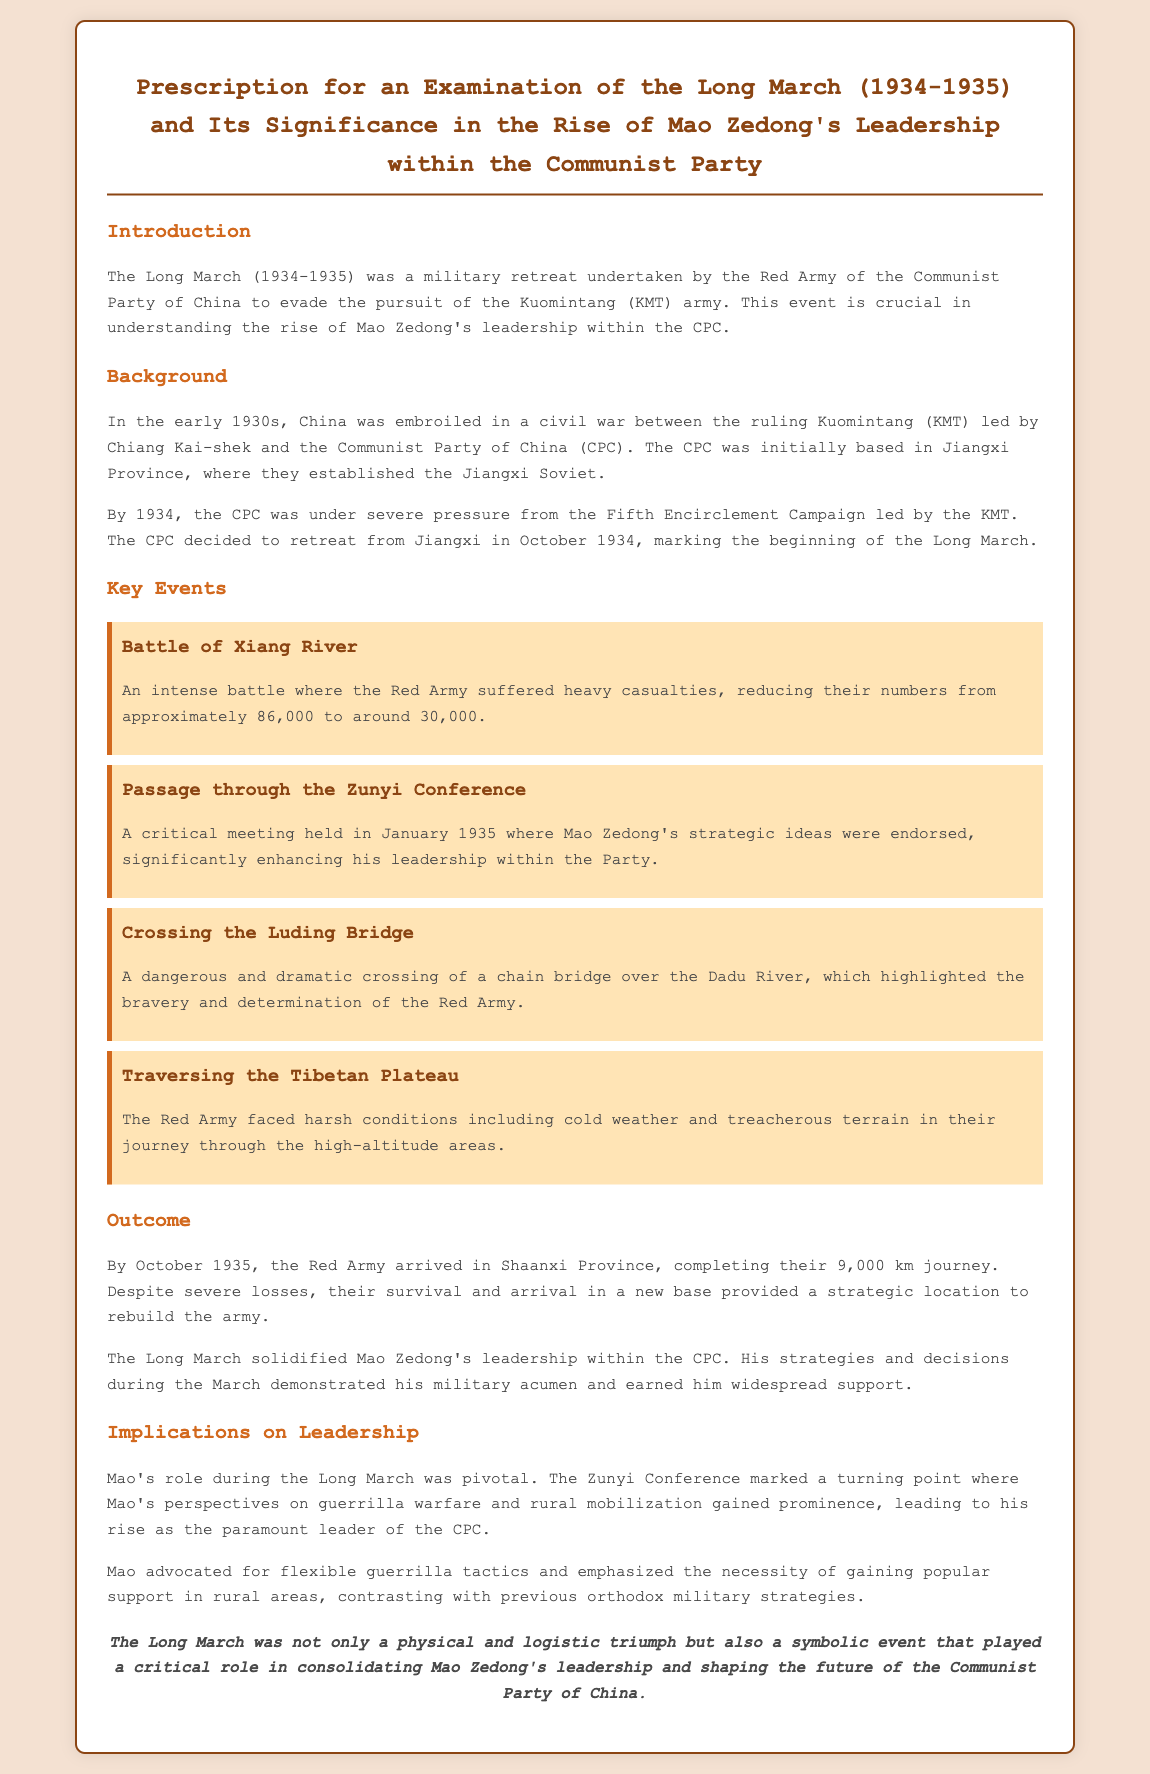what years did the Long March take place? The document states that the Long March occurred during the years 1934-1935.
Answer: 1934-1935 what was the starting point of the Long March? The document mentions that the CPC initially based in Jiangxi Province decided to retreat from there, marking the start of the Long March.
Answer: Jiangxi Province how many soldiers remained after the Battle of Xiang River? The document indicates that the Red Army's numbers reduced from approximately 86,000 to around 30,000 after this battle.
Answer: around 30,000 what significant event occurred during the Zunyi Conference? The Zunyi Conference was a critical meeting where Mao Zedong's strategic ideas were endorsed, which significantly enhanced his leadership.
Answer: Mao's strategies were endorsed what was Mao's tactical emphasis during the Long March? The document states that Mao advocated for flexible guerrilla tactics and gaining popular support in rural areas.
Answer: flexible guerrilla tactics how far did the Red Army travel during the Long March? The document specifies that the Red Army completed a journey of 9,000 km by October 1935.
Answer: 9,000 km what type of document is this? The document is structured as a prescription that examines the significance of the Long March concerning Mao Zedong's leadership within the Communist Party.
Answer: Prescription what geographical challenge did the Red Army face while crossing the Tibetan Plateau? The Red Army faced harsh conditions including cold weather and treacherous terrain in this area.
Answer: cold weather and treacherous terrain what did the Long March symbolize for Mao Zedong's leadership? The document concludes that the Long March was a symbolic event that played a critical role in consolidating Mao Zedong's leadership.
Answer: a symbolic event 